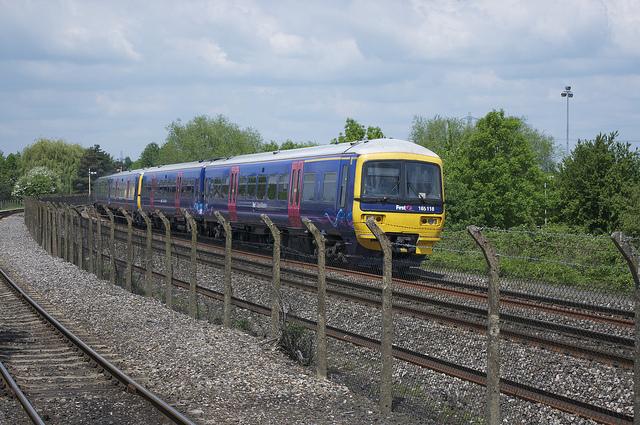How many train cars are there?
Write a very short answer. 3. Are there people waiting at the train station?
Answer briefly. No. What color is the front of the train?
Concise answer only. Yellow. Did she get off at her stop?
Give a very brief answer. Yes. 